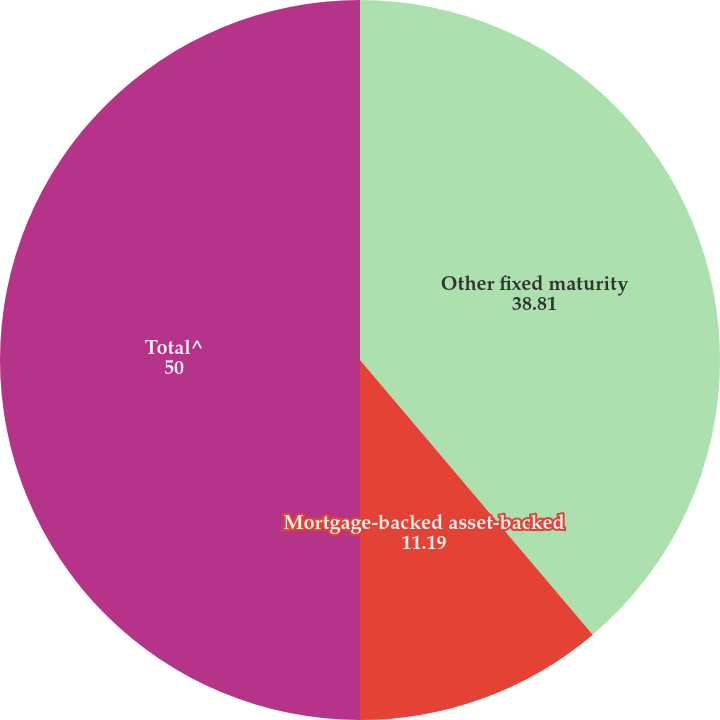<chart> <loc_0><loc_0><loc_500><loc_500><pie_chart><fcel>Other fixed maturity<fcel>Mortgage-backed asset-backed<fcel>Total^<nl><fcel>38.81%<fcel>11.19%<fcel>50.0%<nl></chart> 